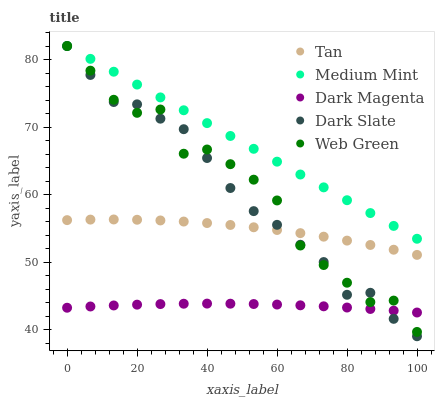Does Dark Magenta have the minimum area under the curve?
Answer yes or no. Yes. Does Medium Mint have the maximum area under the curve?
Answer yes or no. Yes. Does Dark Slate have the minimum area under the curve?
Answer yes or no. No. Does Dark Slate have the maximum area under the curve?
Answer yes or no. No. Is Medium Mint the smoothest?
Answer yes or no. Yes. Is Web Green the roughest?
Answer yes or no. Yes. Is Dark Slate the smoothest?
Answer yes or no. No. Is Dark Slate the roughest?
Answer yes or no. No. Does Dark Slate have the lowest value?
Answer yes or no. Yes. Does Tan have the lowest value?
Answer yes or no. No. Does Web Green have the highest value?
Answer yes or no. Yes. Does Tan have the highest value?
Answer yes or no. No. Is Dark Magenta less than Medium Mint?
Answer yes or no. Yes. Is Tan greater than Dark Magenta?
Answer yes or no. Yes. Does Web Green intersect Dark Magenta?
Answer yes or no. Yes. Is Web Green less than Dark Magenta?
Answer yes or no. No. Is Web Green greater than Dark Magenta?
Answer yes or no. No. Does Dark Magenta intersect Medium Mint?
Answer yes or no. No. 